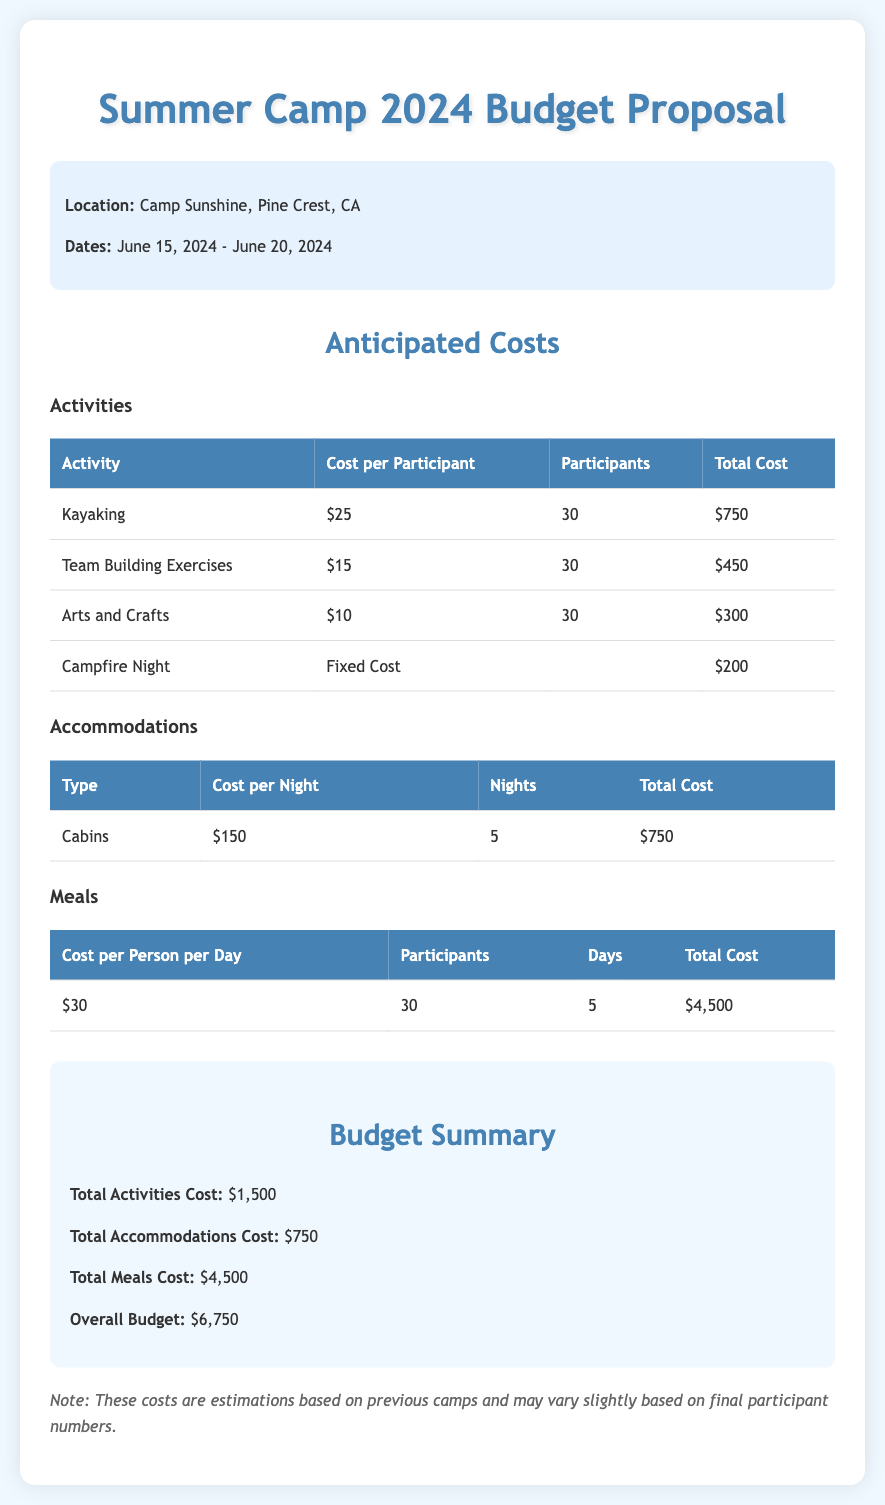What is the total activities cost? The total activities cost is provided in the budget summary as a total for all activities listed in the activities section, which is $1,500.
Answer: $1,500 What is the location of the camp? The location is stated at the beginning of the document as Camp Sunshine, Pine Crest, CA.
Answer: Camp Sunshine, Pine Crest, CA How many nights will accommodations be provided? The number of nights is mentioned under the accommodations section, indicating 5 nights for the cabins.
Answer: 5 What is the cost per person for meals? The cost per person for meals is listed in the meals table as $30.
Answer: $30 How much is allocated for team-building exercises? The amount allocated for team-building exercises is calculated as the cost per participant multiplied by the number of participants, which equals $450.
Answer: $450 What is the total budget for the summer camp? The total budget is stated in the budget summary as the overall amount for activities, accommodations, and meals added together, which is $6,750.
Answer: $6,750 What activities are included in the proposal? The activities listed include Kayaking, Team Building Exercises, Arts and Crafts, and Campfire Night.
Answer: Kayaking, Team Building Exercises, Arts and Crafts, Campfire Night What is the fixed cost for Campfire Night? The fixed cost for Campfire Night is indicated in the activities table as $200.
Answer: $200 How many participants are expected for the camp activities? The expected number of participants for the camp activities, as noted in the activities section, is 30.
Answer: 30 